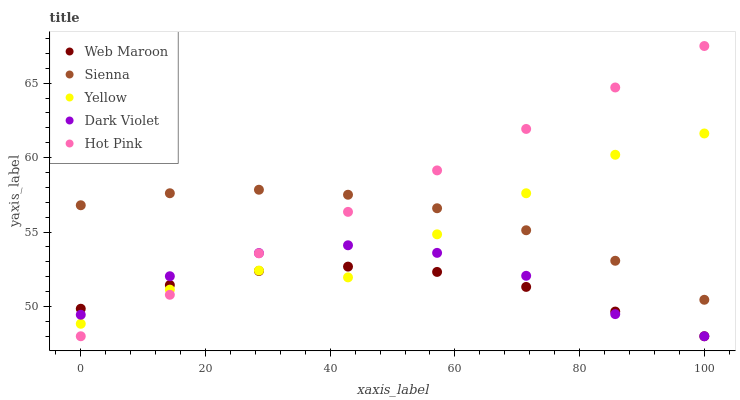Does Web Maroon have the minimum area under the curve?
Answer yes or no. Yes. Does Hot Pink have the maximum area under the curve?
Answer yes or no. Yes. Does Hot Pink have the minimum area under the curve?
Answer yes or no. No. Does Web Maroon have the maximum area under the curve?
Answer yes or no. No. Is Hot Pink the smoothest?
Answer yes or no. Yes. Is Yellow the roughest?
Answer yes or no. Yes. Is Web Maroon the smoothest?
Answer yes or no. No. Is Web Maroon the roughest?
Answer yes or no. No. Does Hot Pink have the lowest value?
Answer yes or no. Yes. Does Yellow have the lowest value?
Answer yes or no. No. Does Hot Pink have the highest value?
Answer yes or no. Yes. Does Web Maroon have the highest value?
Answer yes or no. No. Is Dark Violet less than Sienna?
Answer yes or no. Yes. Is Sienna greater than Dark Violet?
Answer yes or no. Yes. Does Yellow intersect Web Maroon?
Answer yes or no. Yes. Is Yellow less than Web Maroon?
Answer yes or no. No. Is Yellow greater than Web Maroon?
Answer yes or no. No. Does Dark Violet intersect Sienna?
Answer yes or no. No. 